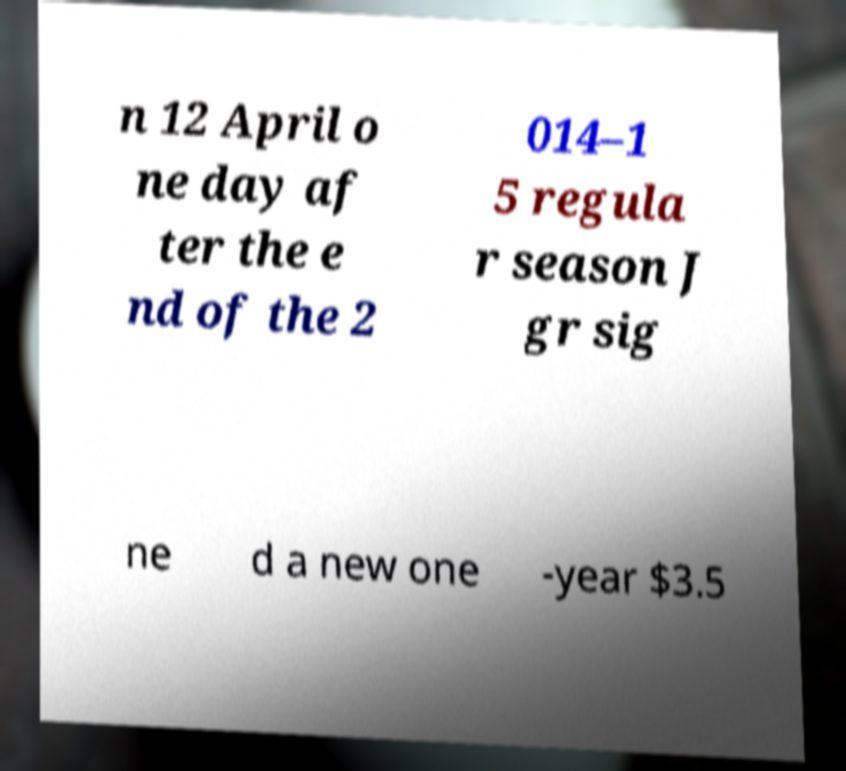For documentation purposes, I need the text within this image transcribed. Could you provide that? n 12 April o ne day af ter the e nd of the 2 014–1 5 regula r season J gr sig ne d a new one -year $3.5 